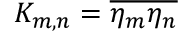Convert formula to latex. <formula><loc_0><loc_0><loc_500><loc_500>K _ { m , n } = \overline { { \eta _ { m } \eta _ { n } } }</formula> 